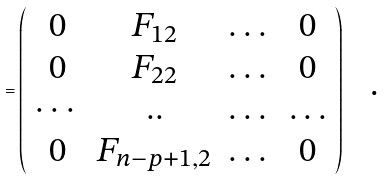<formula> <loc_0><loc_0><loc_500><loc_500>= \left ( \begin{array} { c c c c } 0 & F _ { 1 2 } & \dots & 0 \\ 0 & F _ { 2 2 } & \dots & 0 \\ \cdots & . . & \dots & \dots \\ 0 & F _ { n - p + 1 , 2 } & \dots & 0 \end{array} \right ) \text { \ \ .}</formula> 